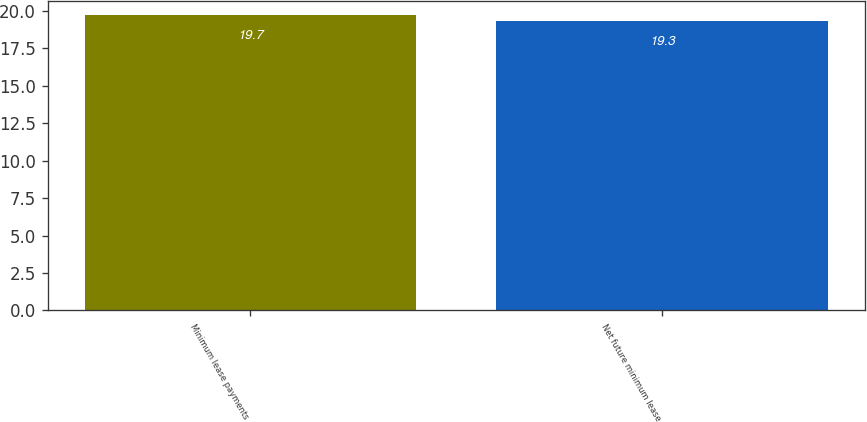<chart> <loc_0><loc_0><loc_500><loc_500><bar_chart><fcel>Minimum lease payments<fcel>Net future minimum lease<nl><fcel>19.7<fcel>19.3<nl></chart> 